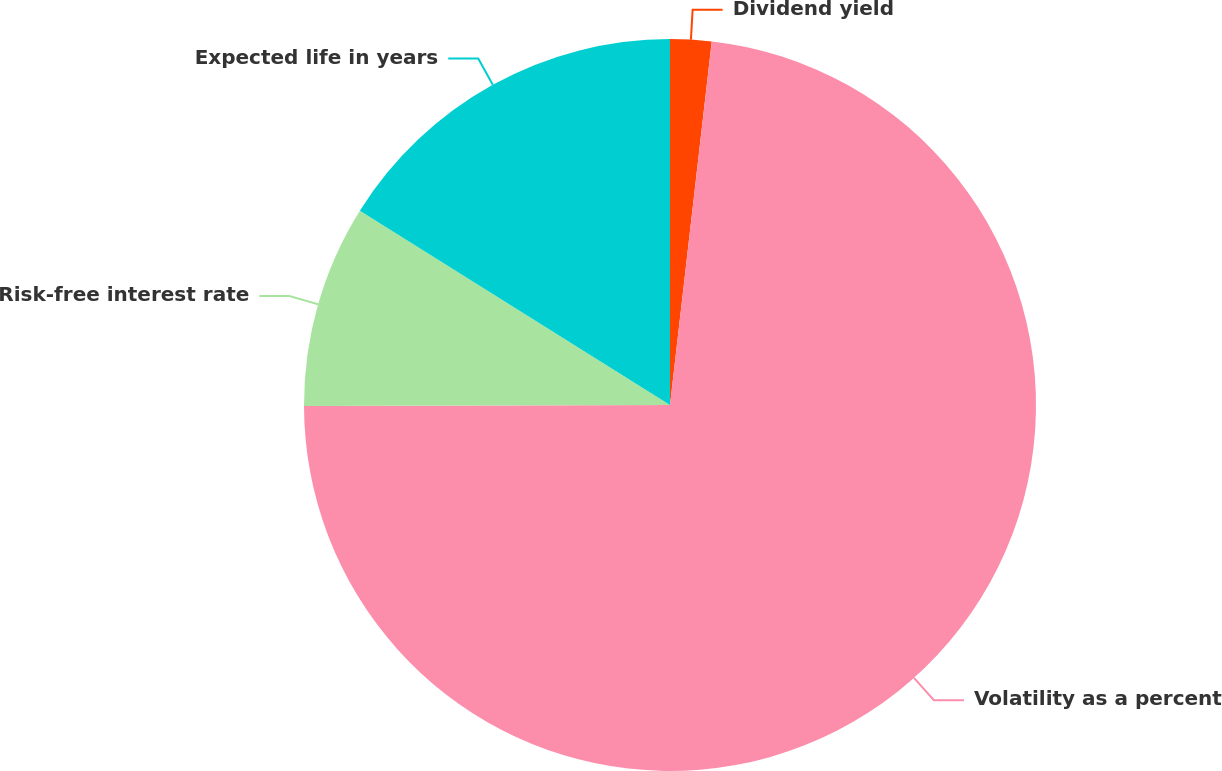Convert chart to OTSL. <chart><loc_0><loc_0><loc_500><loc_500><pie_chart><fcel>Dividend yield<fcel>Volatility as a percent<fcel>Risk-free interest rate<fcel>Expected life in years<nl><fcel>1.82%<fcel>73.14%<fcel>8.95%<fcel>16.09%<nl></chart> 